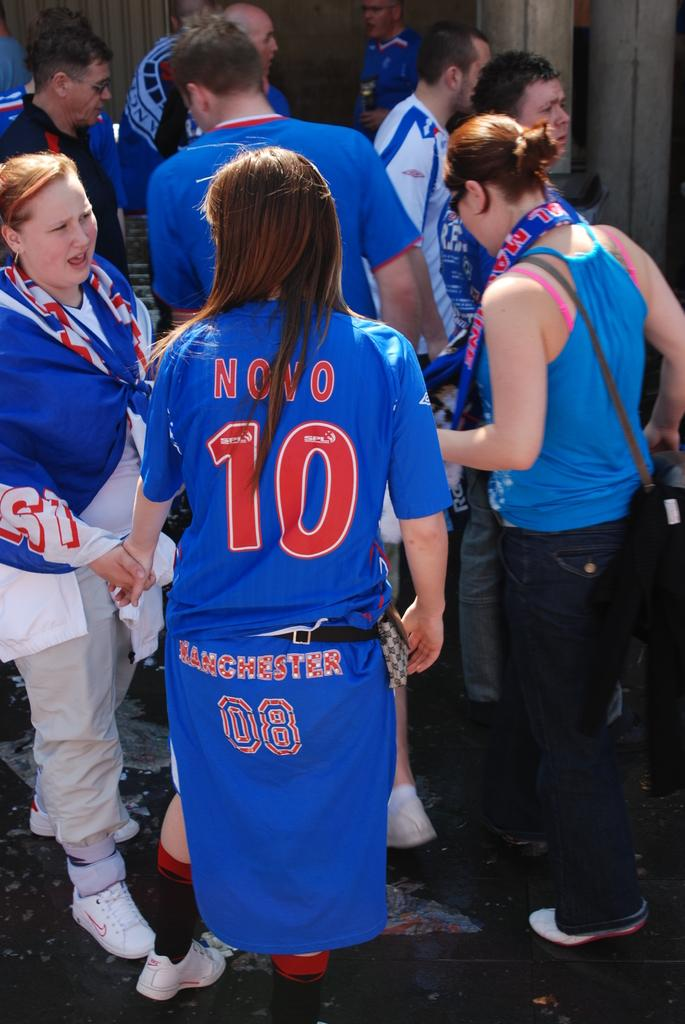<image>
Relay a brief, clear account of the picture shown. manchester team member novo number 10 with her back turned 